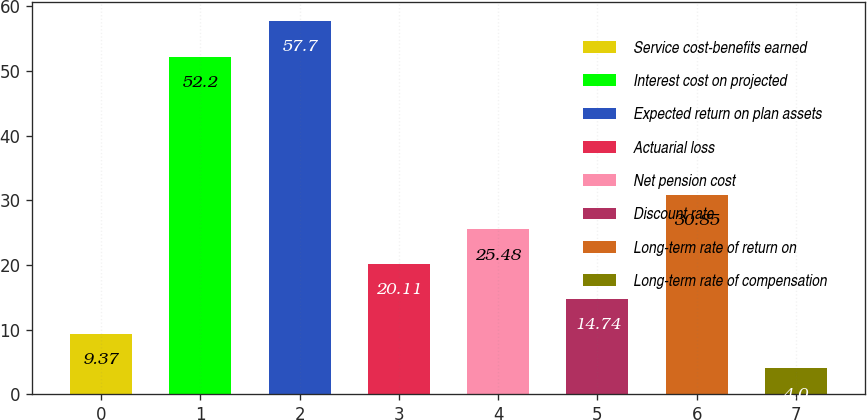Convert chart. <chart><loc_0><loc_0><loc_500><loc_500><bar_chart><fcel>Service cost-benefits earned<fcel>Interest cost on projected<fcel>Expected return on plan assets<fcel>Actuarial loss<fcel>Net pension cost<fcel>Discount rate<fcel>Long-term rate of return on<fcel>Long-term rate of compensation<nl><fcel>9.37<fcel>52.2<fcel>57.7<fcel>20.11<fcel>25.48<fcel>14.74<fcel>30.85<fcel>4<nl></chart> 